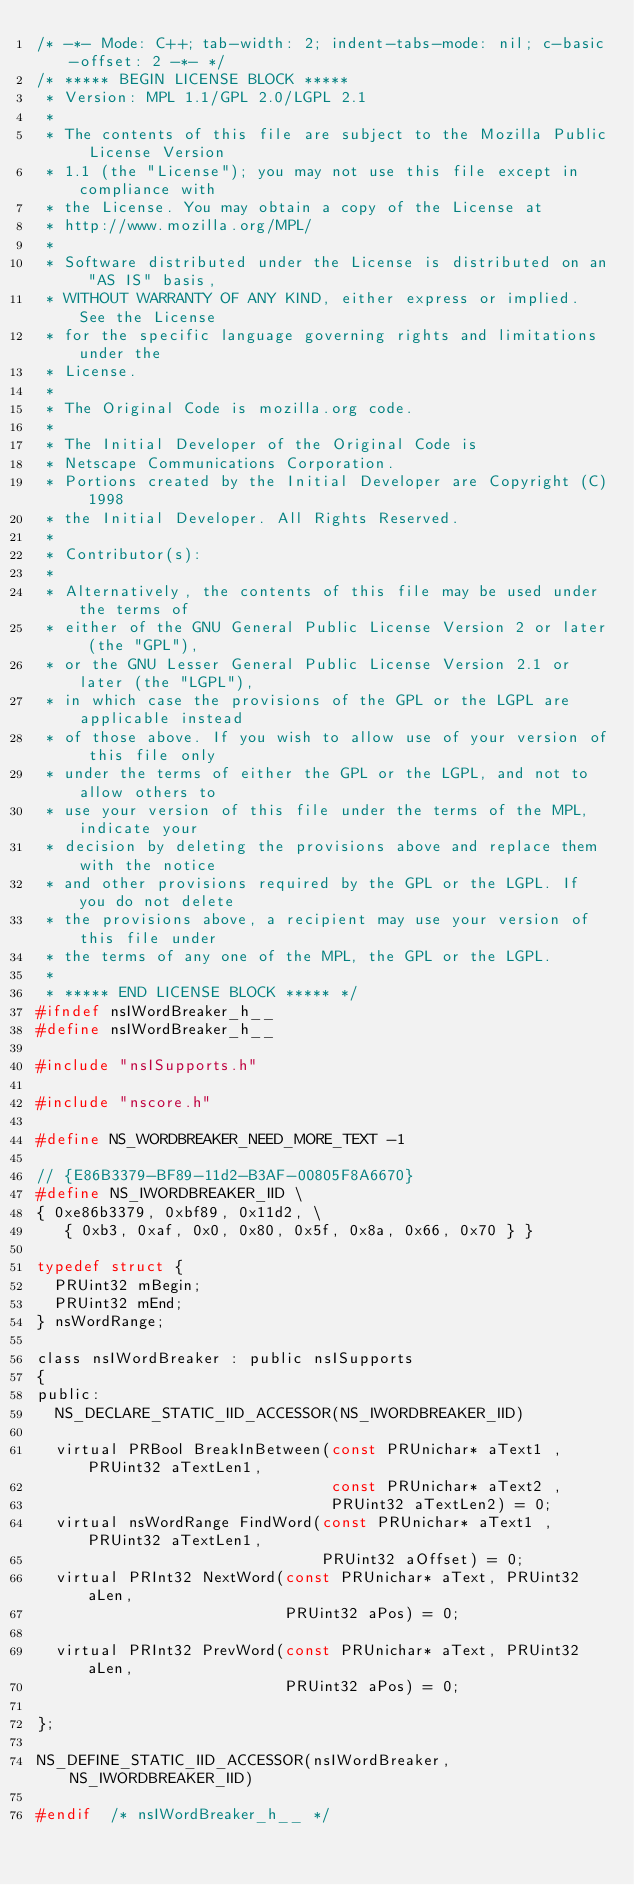Convert code to text. <code><loc_0><loc_0><loc_500><loc_500><_C_>/* -*- Mode: C++; tab-width: 2; indent-tabs-mode: nil; c-basic-offset: 2 -*- */
/* ***** BEGIN LICENSE BLOCK *****
 * Version: MPL 1.1/GPL 2.0/LGPL 2.1
 *
 * The contents of this file are subject to the Mozilla Public License Version
 * 1.1 (the "License"); you may not use this file except in compliance with
 * the License. You may obtain a copy of the License at
 * http://www.mozilla.org/MPL/
 *
 * Software distributed under the License is distributed on an "AS IS" basis,
 * WITHOUT WARRANTY OF ANY KIND, either express or implied. See the License
 * for the specific language governing rights and limitations under the
 * License.
 *
 * The Original Code is mozilla.org code.
 *
 * The Initial Developer of the Original Code is
 * Netscape Communications Corporation.
 * Portions created by the Initial Developer are Copyright (C) 1998
 * the Initial Developer. All Rights Reserved.
 *
 * Contributor(s):
 *
 * Alternatively, the contents of this file may be used under the terms of
 * either of the GNU General Public License Version 2 or later (the "GPL"),
 * or the GNU Lesser General Public License Version 2.1 or later (the "LGPL"),
 * in which case the provisions of the GPL or the LGPL are applicable instead
 * of those above. If you wish to allow use of your version of this file only
 * under the terms of either the GPL or the LGPL, and not to allow others to
 * use your version of this file under the terms of the MPL, indicate your
 * decision by deleting the provisions above and replace them with the notice
 * and other provisions required by the GPL or the LGPL. If you do not delete
 * the provisions above, a recipient may use your version of this file under
 * the terms of any one of the MPL, the GPL or the LGPL.
 *
 * ***** END LICENSE BLOCK ***** */
#ifndef nsIWordBreaker_h__
#define nsIWordBreaker_h__

#include "nsISupports.h"

#include "nscore.h"

#define NS_WORDBREAKER_NEED_MORE_TEXT -1

// {E86B3379-BF89-11d2-B3AF-00805F8A6670}
#define NS_IWORDBREAKER_IID \
{ 0xe86b3379, 0xbf89, 0x11d2, \
   { 0xb3, 0xaf, 0x0, 0x80, 0x5f, 0x8a, 0x66, 0x70 } }

typedef struct {
  PRUint32 mBegin;
  PRUint32 mEnd;
} nsWordRange;

class nsIWordBreaker : public nsISupports
{
public:
  NS_DECLARE_STATIC_IID_ACCESSOR(NS_IWORDBREAKER_IID)

  virtual PRBool BreakInBetween(const PRUnichar* aText1 , PRUint32 aTextLen1,
                                const PRUnichar* aText2 ,
                                PRUint32 aTextLen2) = 0;
  virtual nsWordRange FindWord(const PRUnichar* aText1 , PRUint32 aTextLen1,
                               PRUint32 aOffset) = 0;
  virtual PRInt32 NextWord(const PRUnichar* aText, PRUint32 aLen, 
                           PRUint32 aPos) = 0;
                           
  virtual PRInt32 PrevWord(const PRUnichar* aText, PRUint32 aLen, 
                           PRUint32 aPos) = 0;

};

NS_DEFINE_STATIC_IID_ACCESSOR(nsIWordBreaker, NS_IWORDBREAKER_IID)

#endif  /* nsIWordBreaker_h__ */
</code> 